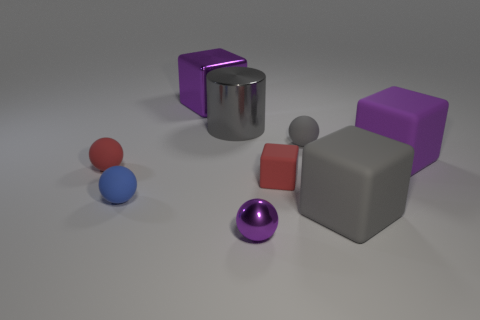Do the purple matte block and the shiny cube have the same size?
Keep it short and to the point. Yes. What is the large gray cylinder made of?
Give a very brief answer. Metal. What is the material of the small ball that is the same color as the tiny block?
Keep it short and to the point. Rubber. There is a tiny blue object left of the metal cube; does it have the same shape as the purple matte thing?
Provide a succinct answer. No. How many things are either large red metallic cylinders or purple blocks?
Offer a very short reply. 2. Are the tiny thing in front of the blue ball and the cylinder made of the same material?
Your response must be concise. Yes. The red sphere has what size?
Give a very brief answer. Small. There is a small rubber object that is the same color as the cylinder; what shape is it?
Offer a terse response. Sphere. How many cylinders are either big blue shiny things or small red rubber things?
Make the answer very short. 0. Are there the same number of tiny red balls that are behind the large gray metal thing and small spheres that are behind the small red matte sphere?
Your response must be concise. No. 